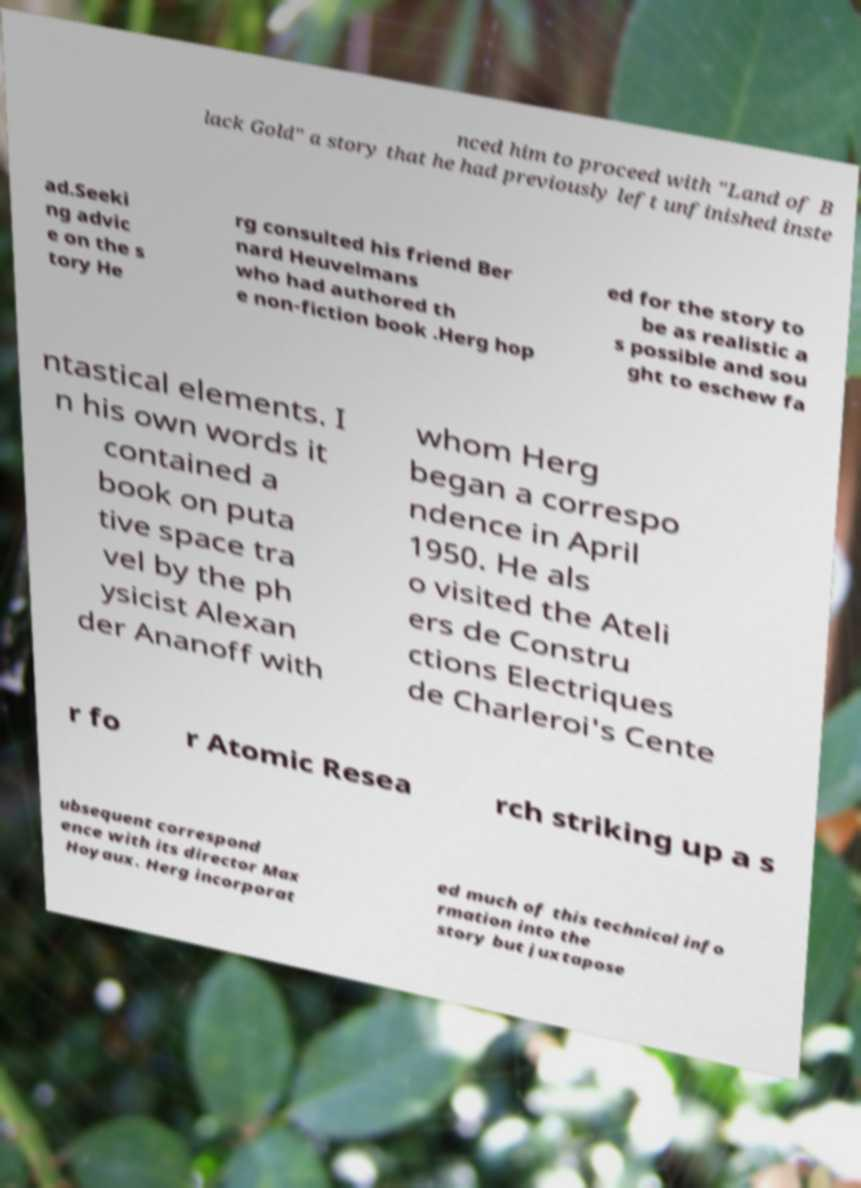What messages or text are displayed in this image? I need them in a readable, typed format. nced him to proceed with "Land of B lack Gold" a story that he had previously left unfinished inste ad.Seeki ng advic e on the s tory He rg consulted his friend Ber nard Heuvelmans who had authored th e non-fiction book .Herg hop ed for the story to be as realistic a s possible and sou ght to eschew fa ntastical elements. I n his own words it contained a book on puta tive space tra vel by the ph ysicist Alexan der Ananoff with whom Herg began a correspo ndence in April 1950. He als o visited the Ateli ers de Constru ctions Electriques de Charleroi's Cente r fo r Atomic Resea rch striking up a s ubsequent correspond ence with its director Max Hoyaux. Herg incorporat ed much of this technical info rmation into the story but juxtapose 